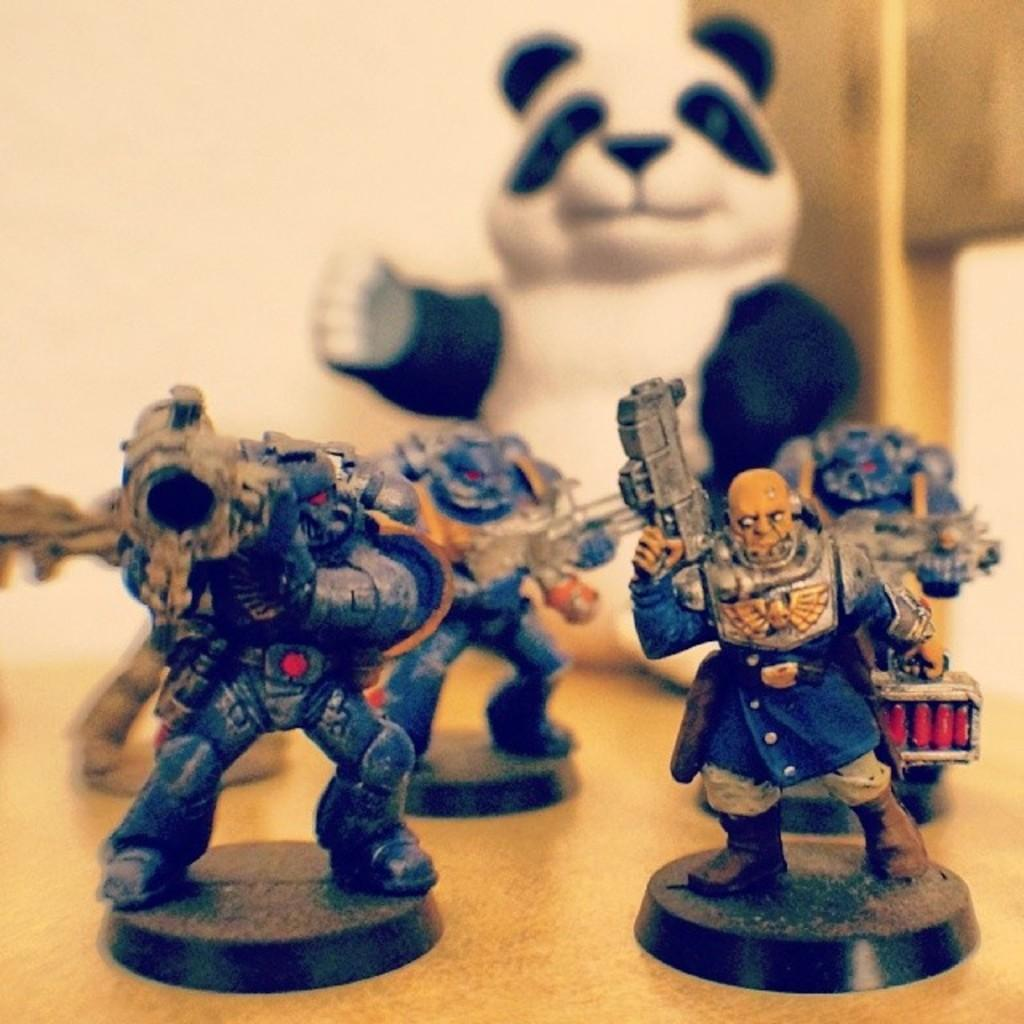What is on the table in the image? There is a group of toys on a table. What can be seen in the background of the image? There is a wall visible in the background of the image. What type of gun is being used by the snail in the image? There is no gun or snail present in the image; it features a group of toys on a table and a wall in the background. 